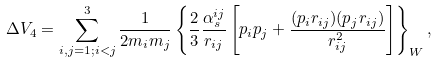Convert formula to latex. <formula><loc_0><loc_0><loc_500><loc_500>\Delta V _ { 4 } = \sum _ { i , j = 1 ; i < j } ^ { 3 } \frac { 1 } { 2 m _ { i } m _ { j } } \left \{ \frac { 2 } { 3 } \frac { \alpha _ { s } ^ { i j } } { r _ { i j } } \left [ { p } _ { i } { p } _ { j } + \frac { ( { p } _ { i } { r } _ { i j } ) ( { p } _ { j } { r } _ { i j } ) } { r _ { i j } ^ { 2 } } \right ] \right \} _ { W } ,</formula> 